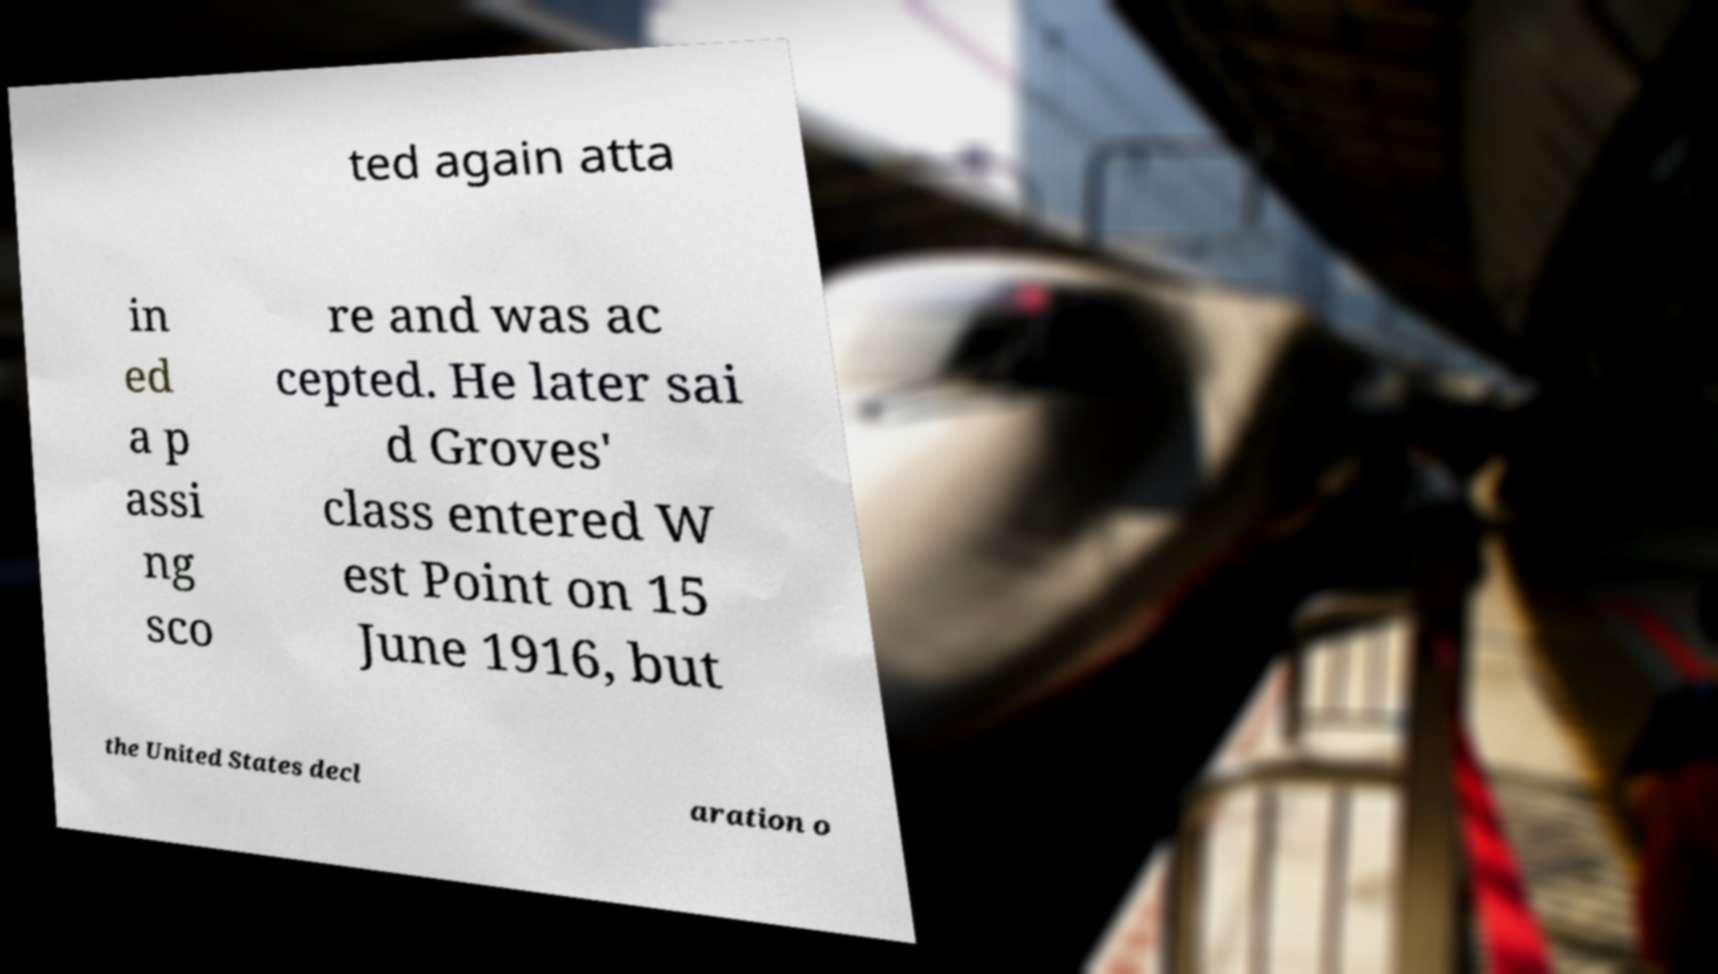Can you accurately transcribe the text from the provided image for me? ted again atta in ed a p assi ng sco re and was ac cepted. He later sai d Groves' class entered W est Point on 15 June 1916, but the United States decl aration o 